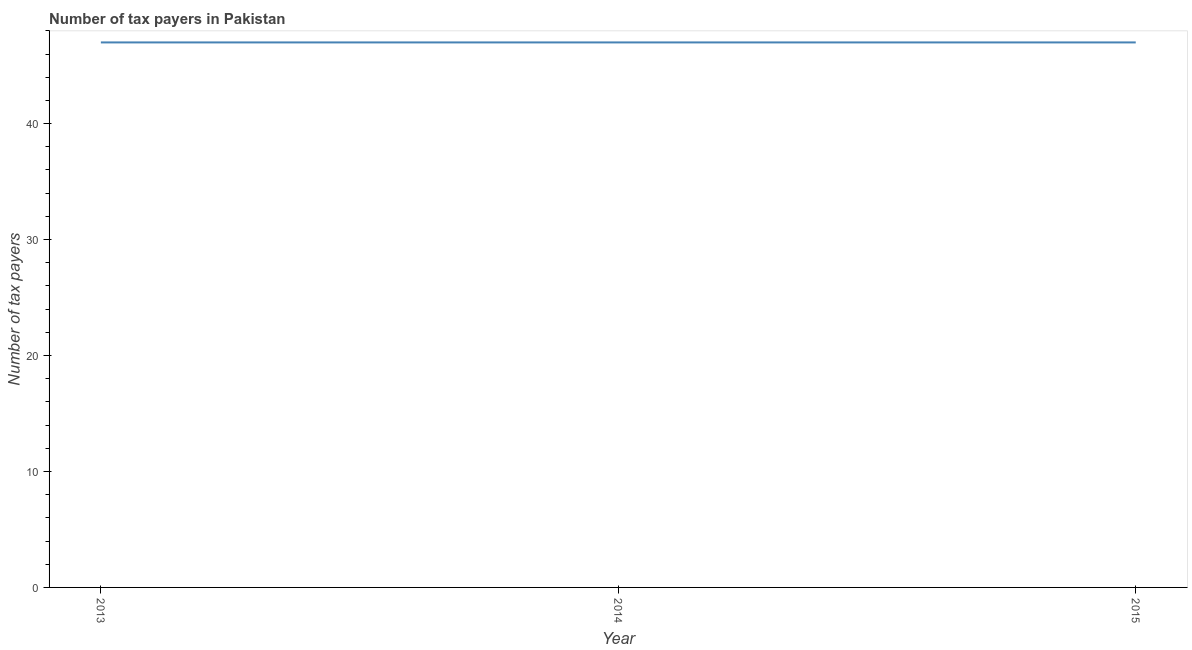What is the number of tax payers in 2015?
Ensure brevity in your answer.  47. Across all years, what is the maximum number of tax payers?
Offer a very short reply. 47. Across all years, what is the minimum number of tax payers?
Provide a succinct answer. 47. In which year was the number of tax payers minimum?
Offer a very short reply. 2013. What is the sum of the number of tax payers?
Your response must be concise. 141. What is the ratio of the number of tax payers in 2013 to that in 2015?
Offer a very short reply. 1. What is the difference between the highest and the second highest number of tax payers?
Ensure brevity in your answer.  0. Is the sum of the number of tax payers in 2013 and 2015 greater than the maximum number of tax payers across all years?
Your answer should be compact. Yes. How many lines are there?
Your answer should be very brief. 1. Are the values on the major ticks of Y-axis written in scientific E-notation?
Ensure brevity in your answer.  No. What is the title of the graph?
Offer a very short reply. Number of tax payers in Pakistan. What is the label or title of the Y-axis?
Give a very brief answer. Number of tax payers. What is the Number of tax payers of 2014?
Give a very brief answer. 47. What is the Number of tax payers in 2015?
Provide a succinct answer. 47. What is the difference between the Number of tax payers in 2014 and 2015?
Provide a short and direct response. 0. What is the ratio of the Number of tax payers in 2013 to that in 2015?
Provide a succinct answer. 1. What is the ratio of the Number of tax payers in 2014 to that in 2015?
Offer a terse response. 1. 